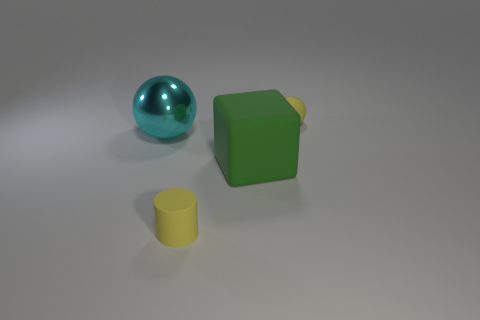Add 1 large green matte objects. How many objects exist? 5 Subtract all yellow spheres. How many spheres are left? 1 Subtract all large green rubber things. Subtract all small yellow matte spheres. How many objects are left? 2 Add 1 cyan metallic things. How many cyan metallic things are left? 2 Add 4 tiny matte balls. How many tiny matte balls exist? 5 Subtract 0 blue cubes. How many objects are left? 4 Subtract all cubes. How many objects are left? 3 Subtract all purple balls. Subtract all green cylinders. How many balls are left? 2 Subtract all blue spheres. How many yellow blocks are left? 0 